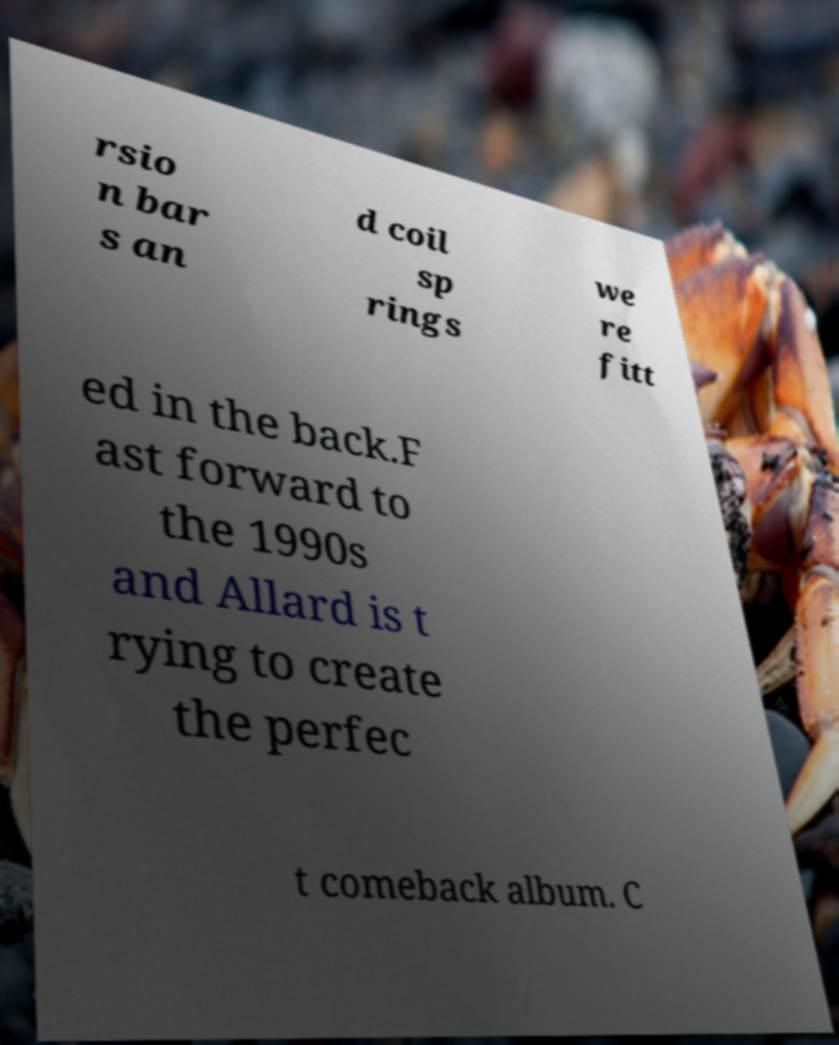Please identify and transcribe the text found in this image. rsio n bar s an d coil sp rings we re fitt ed in the back.F ast forward to the 1990s and Allard is t rying to create the perfec t comeback album. C 